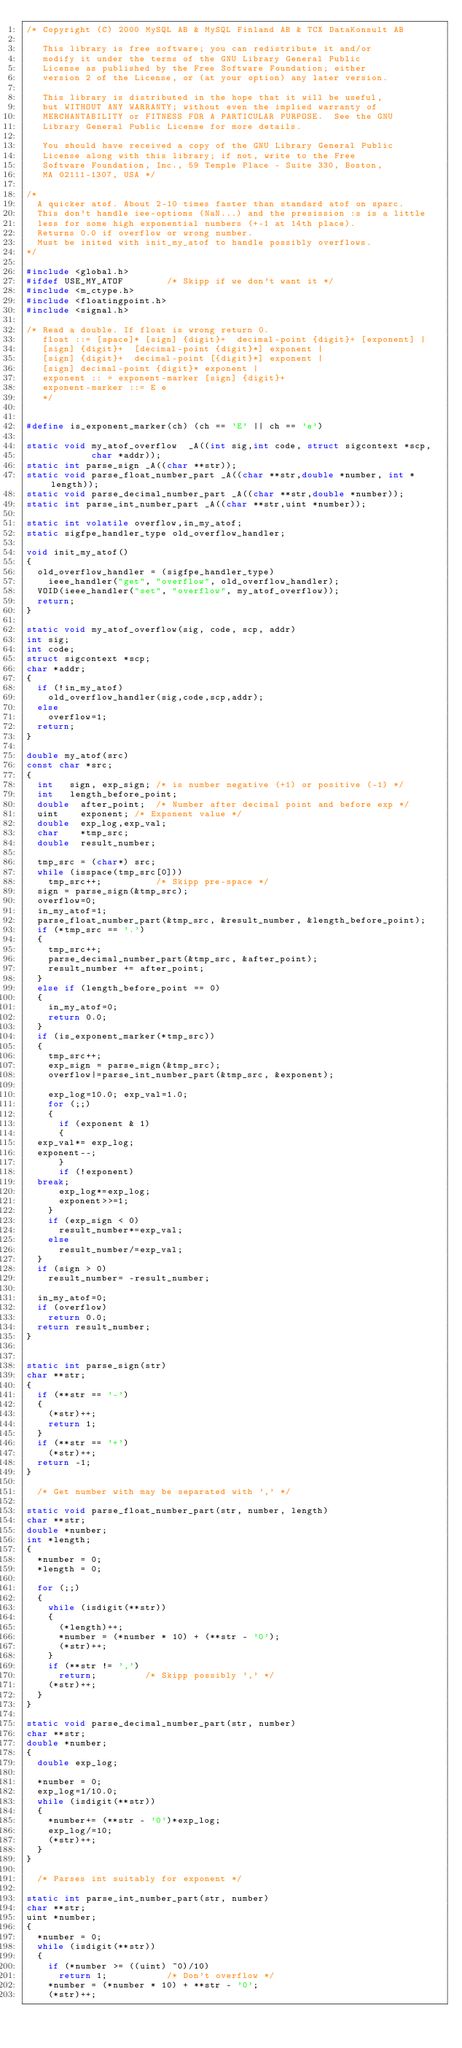<code> <loc_0><loc_0><loc_500><loc_500><_C_>/* Copyright (C) 2000 MySQL AB & MySQL Finland AB & TCX DataKonsult AB
   
   This library is free software; you can redistribute it and/or
   modify it under the terms of the GNU Library General Public
   License as published by the Free Software Foundation; either
   version 2 of the License, or (at your option) any later version.
   
   This library is distributed in the hope that it will be useful,
   but WITHOUT ANY WARRANTY; without even the implied warranty of
   MERCHANTABILITY or FITNESS FOR A PARTICULAR PURPOSE.  See the GNU
   Library General Public License for more details.
   
   You should have received a copy of the GNU Library General Public
   License along with this library; if not, write to the Free
   Software Foundation, Inc., 59 Temple Place - Suite 330, Boston,
   MA 02111-1307, USA */

/*
  A quicker atof. About 2-10 times faster than standard atof on sparc.
  This don't handle iee-options (NaN...) and the presission :s is a little
  less for some high exponential numbers (+-1 at 14th place).
  Returns 0.0 if overflow or wrong number.
  Must be inited with init_my_atof to handle possibly overflows.
*/

#include <global.h>
#ifdef USE_MY_ATOF				/* Skipp if we don't want it */
#include <m_ctype.h>
#include <floatingpoint.h>
#include <signal.h>

/* Read a double. If float is wrong return 0.
   float ::= [space]* [sign] {digit}+  decimal-point {digit}+ [exponent] |
   [sign] {digit}+  [decimal-point {digit}*] exponent |
   [sign] {digit}+  decimal-point [{digit}*] exponent |
   [sign] decimal-point {digit}* exponent |
   exponent :: = exponent-marker [sign] {digit}+
   exponent-marker ::= E e
   */


#define is_exponent_marker(ch) (ch == 'E' || ch == 'e')

static void my_atof_overflow  _A((int sig,int code, struct sigcontext *scp,
			      char *addr));
static int parse_sign _A((char **str));
static void parse_float_number_part _A((char **str,double *number, int *length));
static void parse_decimal_number_part _A((char **str,double *number));
static int parse_int_number_part _A((char **str,uint *number));

static int volatile overflow,in_my_atof;
static sigfpe_handler_type old_overflow_handler;

void init_my_atof()
{
  old_overflow_handler = (sigfpe_handler_type)
    ieee_handler("get", "overflow", old_overflow_handler);
  VOID(ieee_handler("set", "overflow", my_atof_overflow));
  return;
}

static void my_atof_overflow(sig, code, scp, addr)
int sig;
int code;
struct sigcontext *scp;
char *addr;
{
  if (!in_my_atof)
    old_overflow_handler(sig,code,scp,addr);
  else
    overflow=1;
  return;
}

double my_atof(src)
const char *src;
{
  int		sign, exp_sign; /* is number negative (+1) or positive (-1) */
  int		length_before_point;
  double	after_point;	/* Number after decimal point and before exp */
  uint		exponent;	/* Exponent value */
  double	exp_log,exp_val;
  char		*tmp_src;
  double	result_number;

  tmp_src = (char*) src;
  while (isspace(tmp_src[0]))
    tmp_src++;					/* Skipp pre-space */
  sign = parse_sign(&tmp_src);
  overflow=0;
  in_my_atof=1;
  parse_float_number_part(&tmp_src, &result_number, &length_before_point);
  if (*tmp_src == '.')
  {
    tmp_src++;
    parse_decimal_number_part(&tmp_src, &after_point);
    result_number += after_point;
  }
  else if (length_before_point == 0)
  {
    in_my_atof=0;
    return 0.0;
  }
  if (is_exponent_marker(*tmp_src))
  {
    tmp_src++;
    exp_sign = parse_sign(&tmp_src);
    overflow|=parse_int_number_part(&tmp_src, &exponent);

    exp_log=10.0; exp_val=1.0;
    for (;;)
    {
      if (exponent & 1)
      {
	exp_val*= exp_log;
	exponent--;
      }
      if (!exponent)
	break;
      exp_log*=exp_log;
      exponent>>=1;
    }
    if (exp_sign < 0)
      result_number*=exp_val;
    else
      result_number/=exp_val;
  }
  if (sign > 0)
    result_number= -result_number;

  in_my_atof=0;
  if (overflow)
    return 0.0;
  return result_number;
}


static int parse_sign(str)
char **str;
{
  if (**str == '-')
  {
    (*str)++;
    return 1;
  }
  if (**str == '+')
    (*str)++;
  return -1;
}

	/* Get number with may be separated with ',' */

static void parse_float_number_part(str, number, length)
char **str;
double *number;
int *length;
{
  *number = 0;
  *length = 0;

  for (;;)
  {
    while (isdigit(**str))
    {
      (*length)++;
      *number = (*number * 10) + (**str - '0');
      (*str)++;
    }
    if (**str != ',')
      return;					/* Skipp possibly ',' */
    (*str)++;
  }
}

static void parse_decimal_number_part(str, number)
char **str;
double *number;
{
  double exp_log;

  *number = 0;
  exp_log=1/10.0;
  while (isdigit(**str))
  {
    *number+= (**str - '0')*exp_log;
    exp_log/=10;
    (*str)++;
  }
}

	/* Parses int suitably for exponent */

static int parse_int_number_part(str, number)
char **str;
uint *number;
{
  *number = 0;
  while (isdigit(**str))
  {
    if (*number >= ((uint) ~0)/10)
      return 1;						/* Don't overflow */
    *number = (*number * 10) + **str - '0';
    (*str)++;</code> 